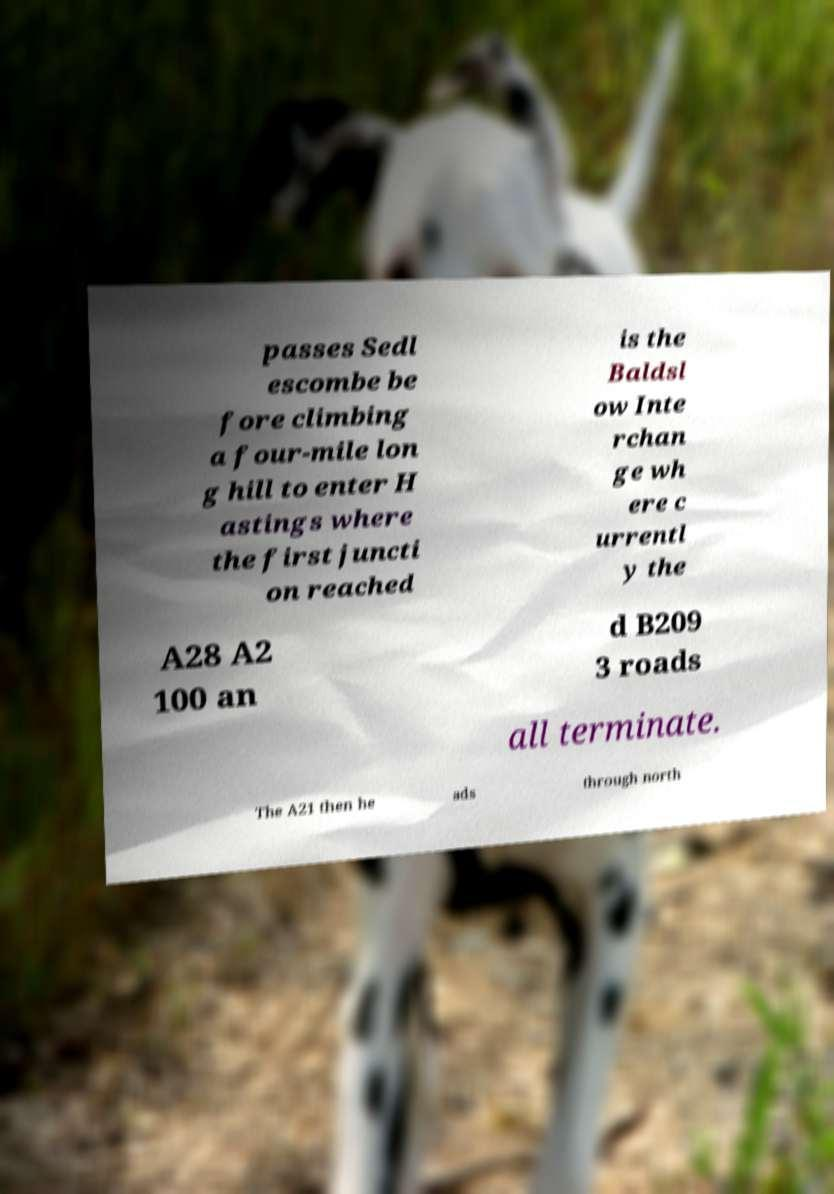Can you accurately transcribe the text from the provided image for me? passes Sedl escombe be fore climbing a four-mile lon g hill to enter H astings where the first juncti on reached is the Baldsl ow Inte rchan ge wh ere c urrentl y the A28 A2 100 an d B209 3 roads all terminate. The A21 then he ads through north 